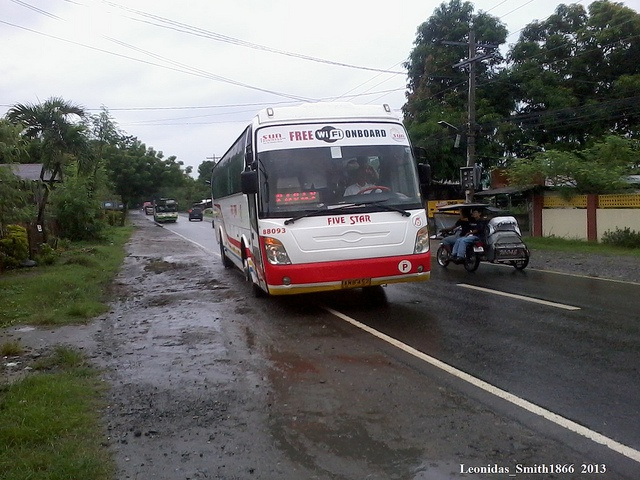Describe the objects in this image and their specific colors. I can see bus in lavender, lightgray, gray, darkgray, and black tones, car in lavender, black, gray, and darkgray tones, people in lavender, black, gray, darkblue, and navy tones, motorcycle in lavender, black, gray, and darkgray tones, and people in lavender, gray, and black tones in this image. 